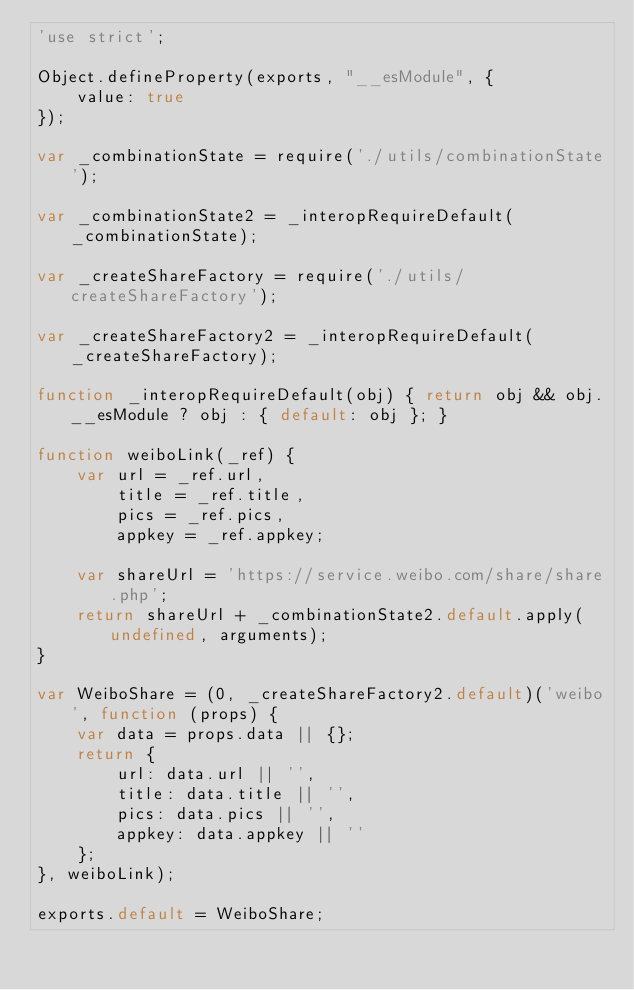<code> <loc_0><loc_0><loc_500><loc_500><_JavaScript_>'use strict';

Object.defineProperty(exports, "__esModule", {
    value: true
});

var _combinationState = require('./utils/combinationState');

var _combinationState2 = _interopRequireDefault(_combinationState);

var _createShareFactory = require('./utils/createShareFactory');

var _createShareFactory2 = _interopRequireDefault(_createShareFactory);

function _interopRequireDefault(obj) { return obj && obj.__esModule ? obj : { default: obj }; }

function weiboLink(_ref) {
    var url = _ref.url,
        title = _ref.title,
        pics = _ref.pics,
        appkey = _ref.appkey;

    var shareUrl = 'https://service.weibo.com/share/share.php';
    return shareUrl + _combinationState2.default.apply(undefined, arguments);
}

var WeiboShare = (0, _createShareFactory2.default)('weibo', function (props) {
    var data = props.data || {};
    return {
        url: data.url || '',
        title: data.title || '',
        pics: data.pics || '',
        appkey: data.appkey || ''
    };
}, weiboLink);

exports.default = WeiboShare;</code> 